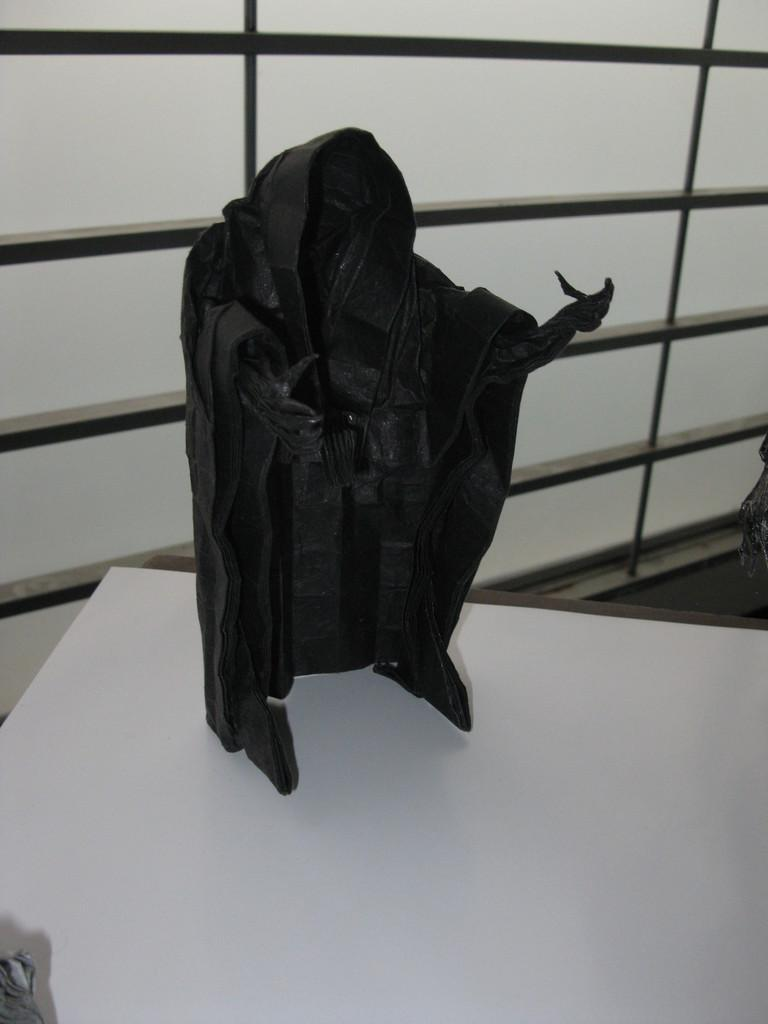What is the color of the main object in the image? The main object in the image is black. What is the color of the surface on which the black object is placed? The black object is on a white surface. What can be seen in the background of the image? There is a window in the background of the image. What type of flower is growing on the black object in the image? There is no flower present on the black object in the image. What type of beef is being prepared in the image? There is no beef or any food preparation visible in the image. 